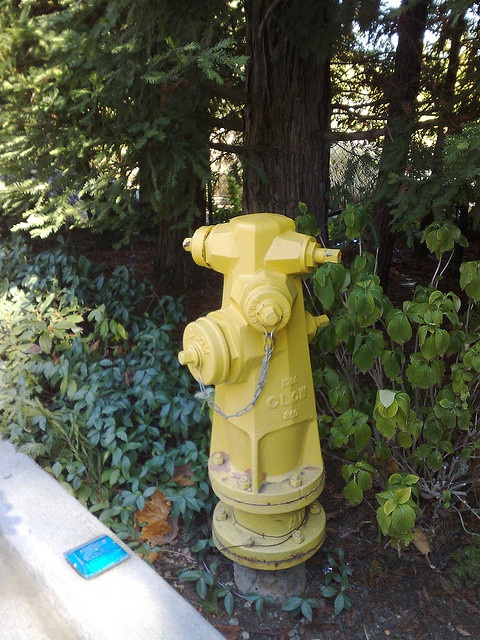Describe the objects in this image and their specific colors. I can see a fire hydrant in black, tan, khaki, and olive tones in this image. 